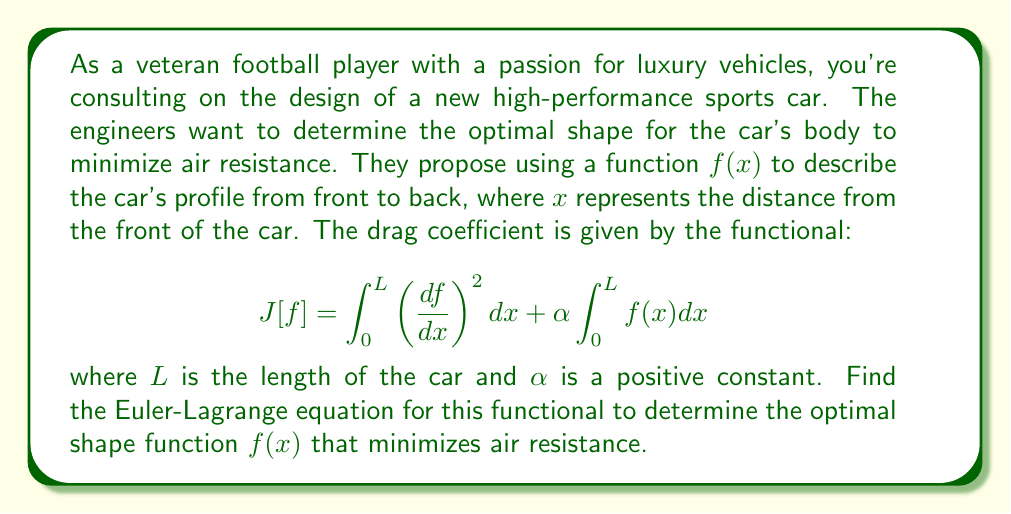What is the answer to this math problem? To solve this problem, we'll use the principles of calculus of variations and follow these steps:

1) The general form of the Euler-Lagrange equation is:

   $$ \frac{\partial F}{\partial f} - \frac{d}{dx}\left(\frac{\partial F}{\partial f'}\right) = 0 $$

   where $F$ is the integrand of our functional.

2) In our case, the functional is:

   $$ J[f] = \int_0^L \left( \frac{df}{dx} \right)^2 dx + \alpha \int_0^L f(x) dx $$

   So, $F = \left(\frac{df}{dx}\right)^2 + \alpha f(x)$

3) Let's calculate the partial derivatives:

   $\frac{\partial F}{\partial f} = \alpha$

   $\frac{\partial F}{\partial f'} = 2\frac{df}{dx}$

4) Now, let's substitute these into the Euler-Lagrange equation:

   $$ \alpha - \frac{d}{dx}\left(2\frac{df}{dx}\right) = 0 $$

5) Simplify:

   $$ \alpha - 2\frac{d^2f}{dx^2} = 0 $$

6) Rearrange to get the final form:

   $$ \frac{d^2f}{dx^2} = \frac{\alpha}{2} $$

This is a second-order ordinary differential equation that describes the optimal shape function $f(x)$ for minimizing air resistance.
Answer: The Euler-Lagrange equation for the optimal aerodynamic shape is:

$$ \frac{d^2f}{dx^2} = \frac{\alpha}{2} $$ 